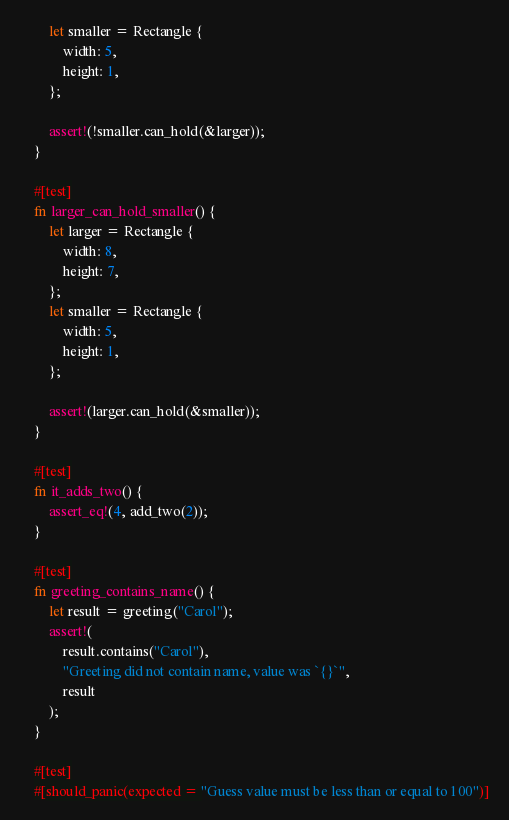Convert code to text. <code><loc_0><loc_0><loc_500><loc_500><_Rust_>        let smaller = Rectangle {
            width: 5,
            height: 1,
        };

        assert!(!smaller.can_hold(&larger));
    }

    #[test]
    fn larger_can_hold_smaller() {
        let larger = Rectangle {
            width: 8,
            height: 7,
        };
        let smaller = Rectangle {
            width: 5,
            height: 1,
        };

        assert!(larger.can_hold(&smaller));
    }

    #[test]
    fn it_adds_two() {
        assert_eq!(4, add_two(2));
    }

    #[test]
    fn greeting_contains_name() {
        let result = greeting("Carol");
        assert!(
            result.contains("Carol"),
            "Greeting did not contain name, value was `{}`",
            result
        );
    }

    #[test]
    #[should_panic(expected = "Guess value must be less than or equal to 100")]</code> 